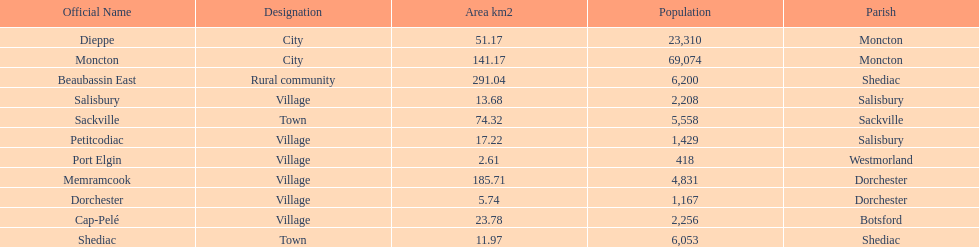City in the same parish of moncton Dieppe. 